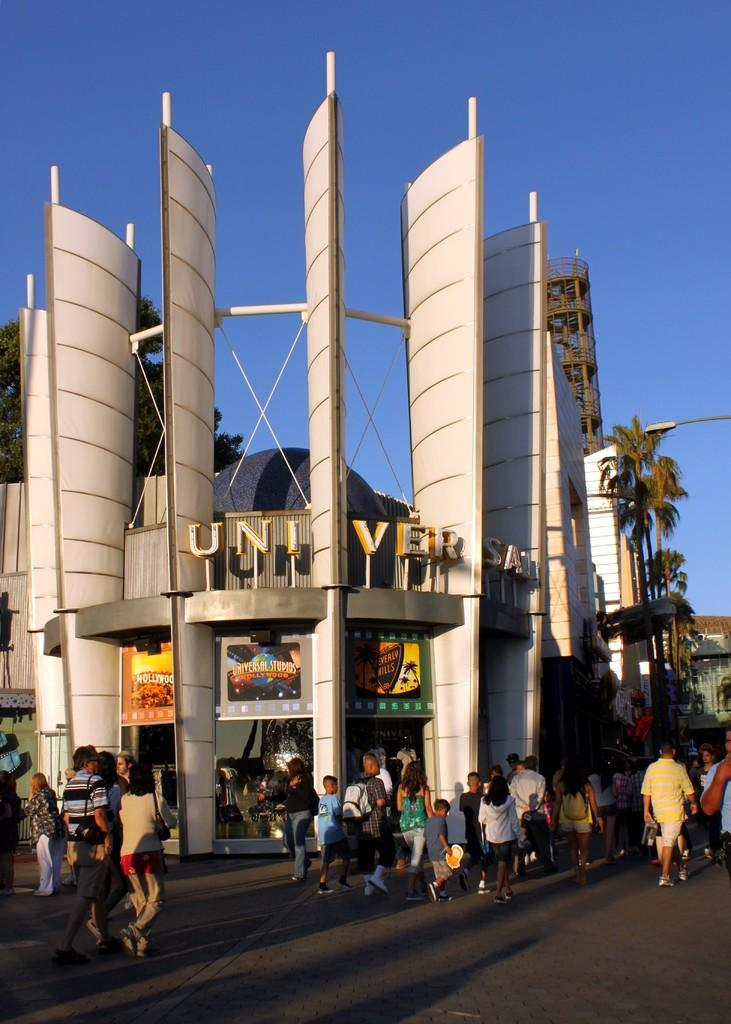What can be seen in the foreground of the image? There are people and posters in the foreground of the image. What else is present in the foreground of the image besides people and posters? There is text in the foreground of the foreground of the image. What is visible in the background of the image? There are buildings, trees, a pole, and the sky in the background of the image. How many patches are visible on the pole in the image? There is no mention of patches on the pole in the image, so it cannot be determined. What type of clocks can be seen hanging from the trees in the image? There are no clocks visible in the image, as the facts provided do not mention any clocks. 